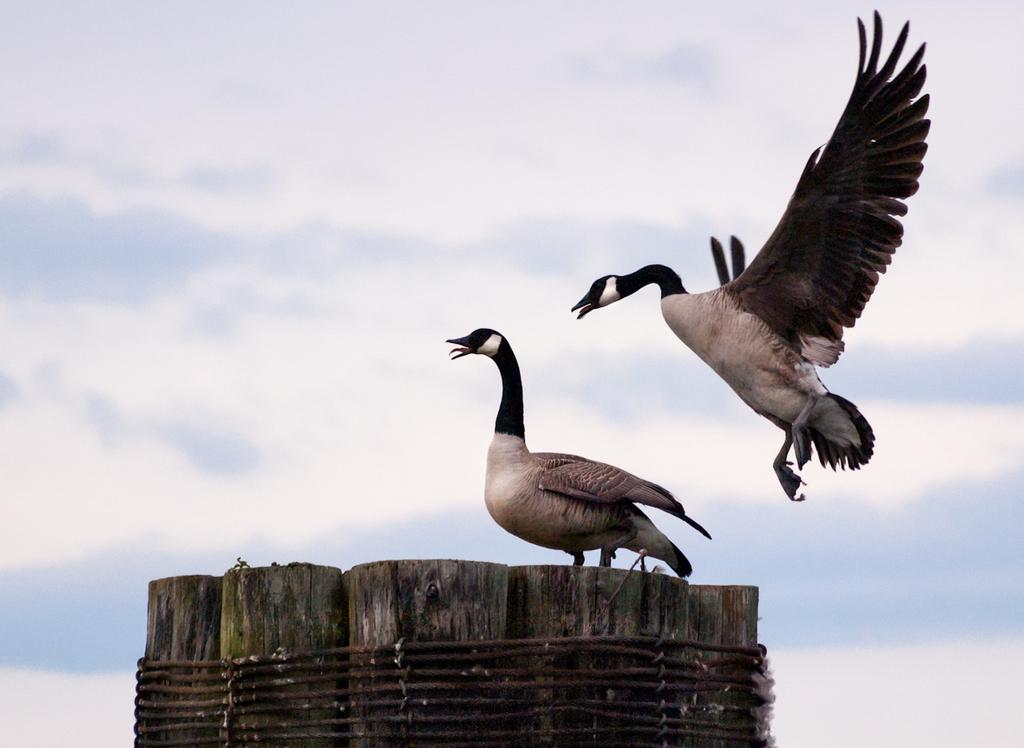How many birds are in the image? There are two birds in the image. What are the colors of the birds? One bird is white in color, and the other bird is black in color. What other objects can be seen in the image? There are wooden logs and a rope in the image. How would you describe the sky in the image? The sky is cloudy in the image. What type of silk material is draped over the plate in the image? There is no silk material or plate present in the image. What holiday is being celebrated in the image? There is no indication of a holiday being celebrated in the image. 